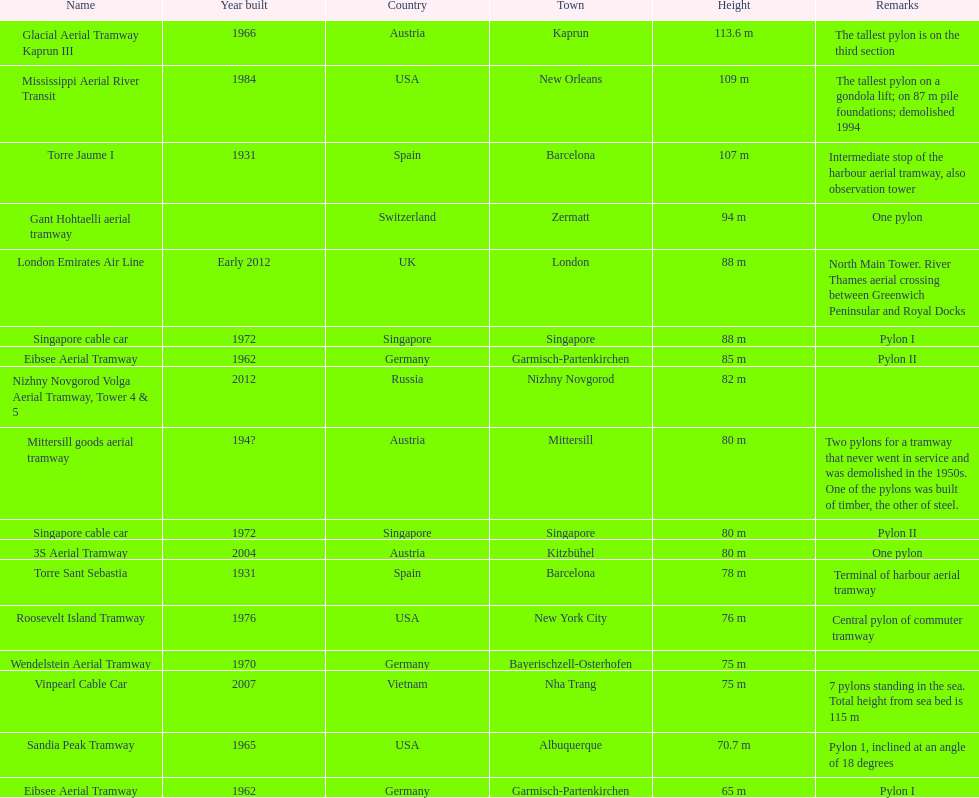Can you identify the pylon with the lowest height from the given list? Eibsee Aerial Tramway. 